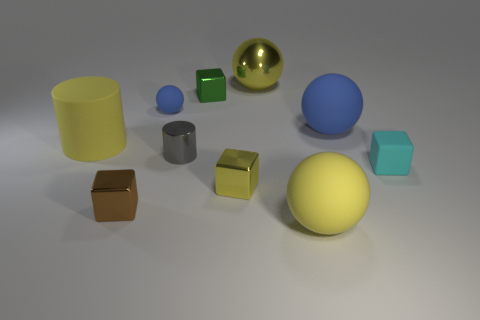How many objects are rubber objects behind the tiny brown cube or rubber spheres in front of the tiny gray thing?
Offer a very short reply. 5. There is a small shiny cube that is behind the small yellow metal object; does it have the same color as the small rubber thing to the right of the gray metallic cylinder?
Your response must be concise. No. There is a tiny thing that is on the left side of the tiny gray thing and behind the cyan object; what shape is it?
Provide a succinct answer. Sphere. There is a shiny cylinder that is the same size as the brown block; what color is it?
Your answer should be very brief. Gray. Are there any objects that have the same color as the big shiny sphere?
Provide a short and direct response. Yes. There is a yellow object behind the tiny green block; is its size the same as the metallic cube behind the cyan object?
Your answer should be compact. No. What material is the block that is both on the left side of the yellow metal ball and behind the tiny yellow metal object?
Provide a succinct answer. Metal. What size is the shiny cube that is the same color as the large cylinder?
Give a very brief answer. Small. What number of other things are there of the same size as the cyan thing?
Offer a very short reply. 5. What material is the yellow sphere that is behind the tiny blue rubber thing?
Provide a short and direct response. Metal. 